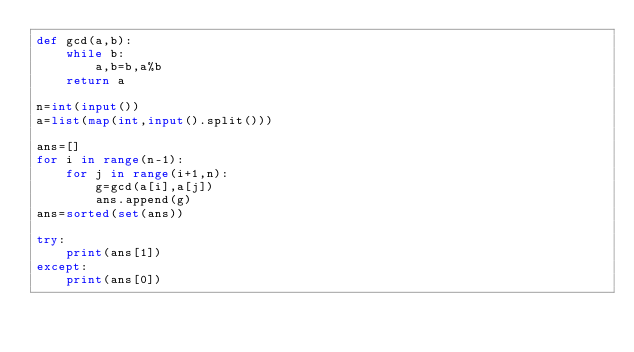Convert code to text. <code><loc_0><loc_0><loc_500><loc_500><_Python_>def gcd(a,b):
    while b:
        a,b=b,a%b
    return a

n=int(input())
a=list(map(int,input().split()))

ans=[]
for i in range(n-1):
    for j in range(i+1,n):
        g=gcd(a[i],a[j])
        ans.append(g)
ans=sorted(set(ans))

try:
    print(ans[1])
except:
    print(ans[0])
</code> 